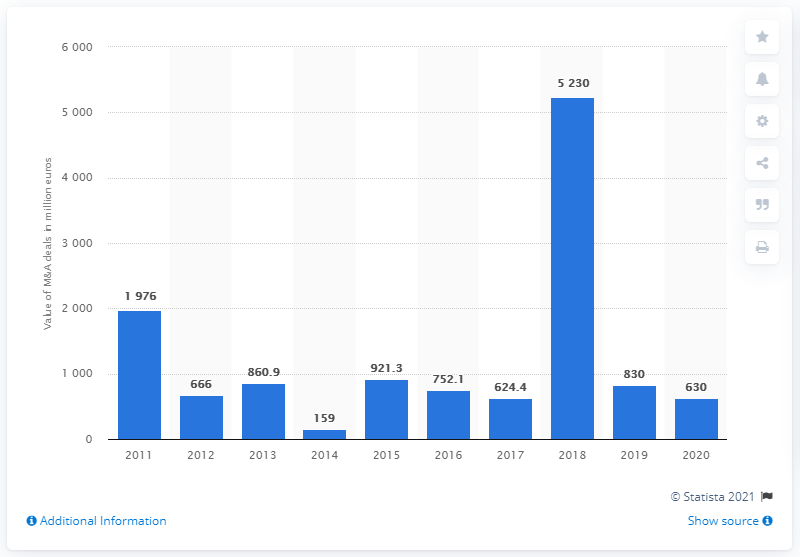Identify some key points in this picture. In the previous year, the value of M&A deals in Serbia was approximately 830. In 2018, the value of mergers and acquisitions (M&A) deals reached 5,230. There were 630 mergers and acquisitions (M&A) deals in Serbia in 2020, with a total value of approximately $X. 